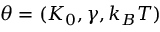<formula> <loc_0><loc_0><loc_500><loc_500>\theta = ( K _ { 0 } , \gamma , k _ { B } T )</formula> 